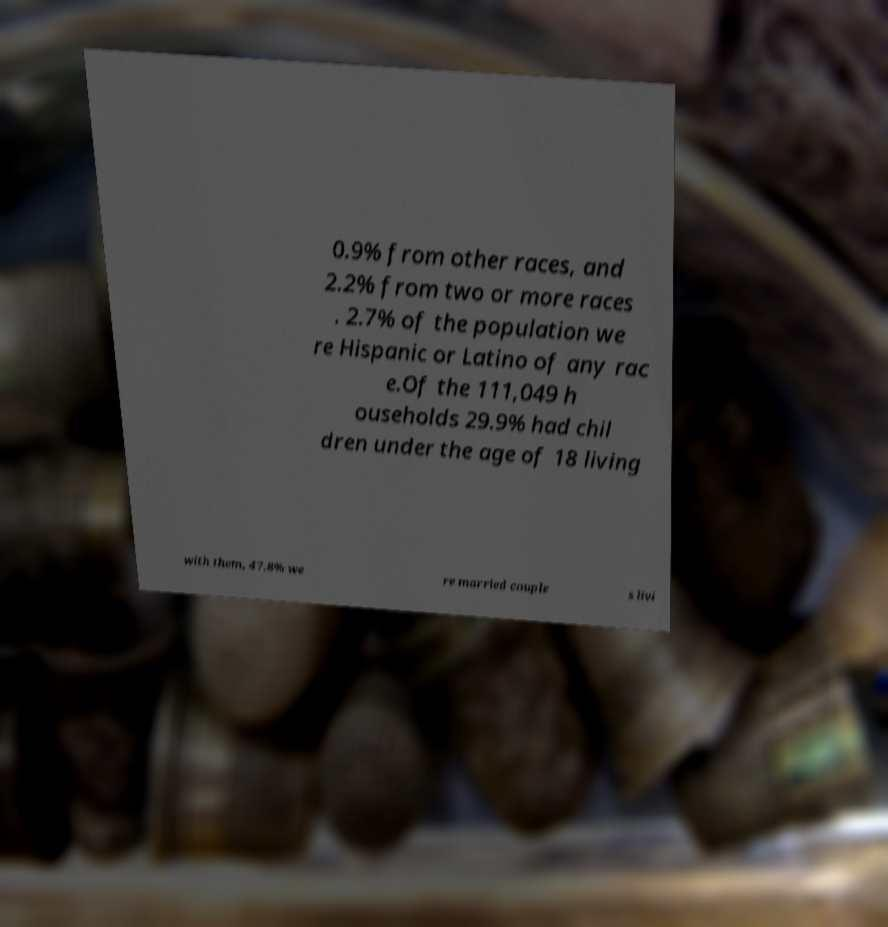For documentation purposes, I need the text within this image transcribed. Could you provide that? 0.9% from other races, and 2.2% from two or more races . 2.7% of the population we re Hispanic or Latino of any rac e.Of the 111,049 h ouseholds 29.9% had chil dren under the age of 18 living with them, 47.8% we re married couple s livi 